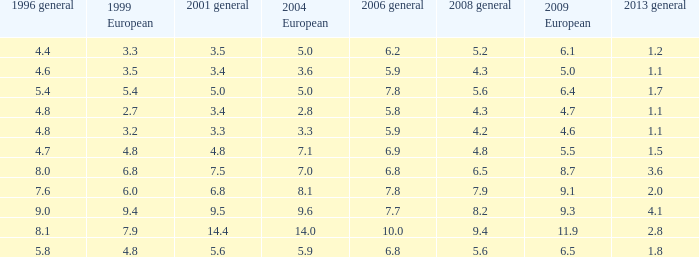How many instances are there of 1999 european values corresponding to 0.0. 